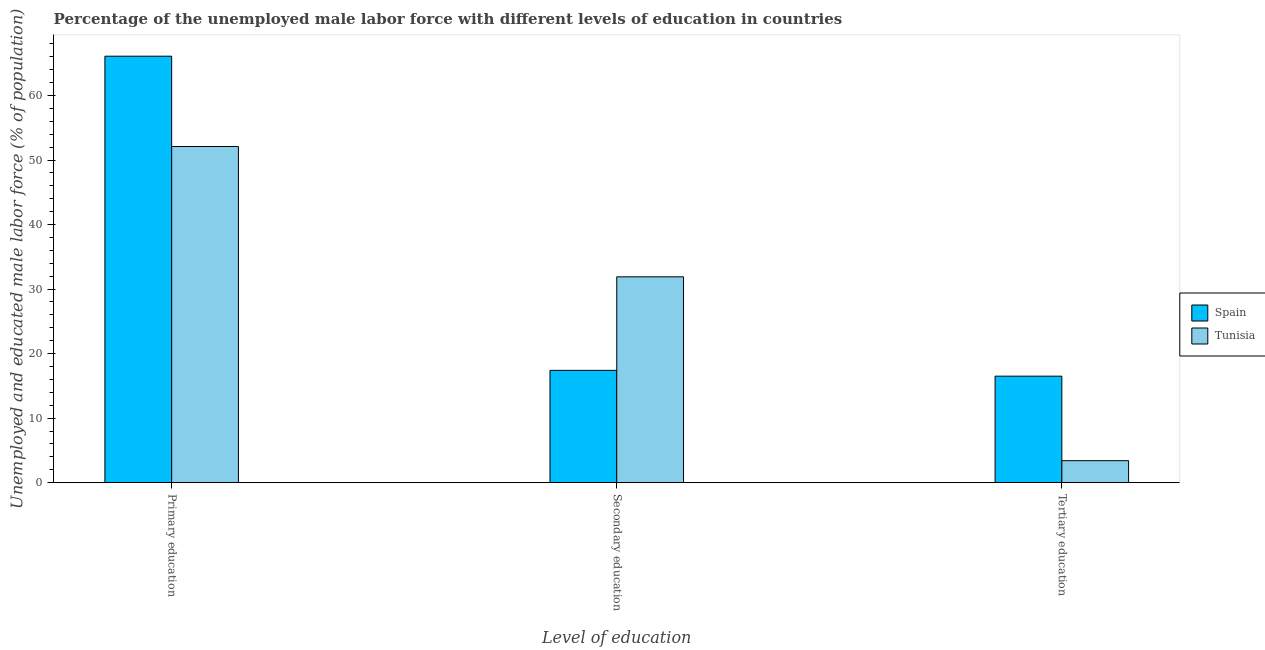How many groups of bars are there?
Make the answer very short. 3. Are the number of bars per tick equal to the number of legend labels?
Give a very brief answer. Yes. Are the number of bars on each tick of the X-axis equal?
Offer a very short reply. Yes. What is the percentage of male labor force who received tertiary education in Spain?
Your answer should be compact. 16.5. Across all countries, what is the maximum percentage of male labor force who received secondary education?
Offer a very short reply. 31.9. Across all countries, what is the minimum percentage of male labor force who received primary education?
Make the answer very short. 52.1. What is the total percentage of male labor force who received tertiary education in the graph?
Your answer should be compact. 19.9. What is the difference between the percentage of male labor force who received tertiary education in Tunisia and that in Spain?
Ensure brevity in your answer.  -13.1. What is the difference between the percentage of male labor force who received tertiary education in Tunisia and the percentage of male labor force who received primary education in Spain?
Offer a very short reply. -62.7. What is the average percentage of male labor force who received secondary education per country?
Offer a terse response. 24.65. What is the difference between the percentage of male labor force who received primary education and percentage of male labor force who received tertiary education in Tunisia?
Offer a very short reply. 48.7. In how many countries, is the percentage of male labor force who received primary education greater than 66 %?
Your response must be concise. 1. What is the ratio of the percentage of male labor force who received primary education in Spain to that in Tunisia?
Your answer should be very brief. 1.27. Is the percentage of male labor force who received primary education in Spain less than that in Tunisia?
Offer a very short reply. No. Is the difference between the percentage of male labor force who received tertiary education in Spain and Tunisia greater than the difference between the percentage of male labor force who received primary education in Spain and Tunisia?
Your answer should be compact. No. What is the difference between the highest and the second highest percentage of male labor force who received tertiary education?
Your response must be concise. 13.1. What is the difference between the highest and the lowest percentage of male labor force who received tertiary education?
Offer a terse response. 13.1. What does the 2nd bar from the left in Tertiary education represents?
Make the answer very short. Tunisia. What does the 2nd bar from the right in Tertiary education represents?
Provide a succinct answer. Spain. How many bars are there?
Offer a very short reply. 6. How many countries are there in the graph?
Provide a short and direct response. 2. Are the values on the major ticks of Y-axis written in scientific E-notation?
Make the answer very short. No. Does the graph contain grids?
Provide a short and direct response. No. How are the legend labels stacked?
Offer a very short reply. Vertical. What is the title of the graph?
Your answer should be very brief. Percentage of the unemployed male labor force with different levels of education in countries. Does "Channel Islands" appear as one of the legend labels in the graph?
Make the answer very short. No. What is the label or title of the X-axis?
Offer a terse response. Level of education. What is the label or title of the Y-axis?
Give a very brief answer. Unemployed and educated male labor force (% of population). What is the Unemployed and educated male labor force (% of population) of Spain in Primary education?
Your answer should be very brief. 66.1. What is the Unemployed and educated male labor force (% of population) in Tunisia in Primary education?
Give a very brief answer. 52.1. What is the Unemployed and educated male labor force (% of population) in Spain in Secondary education?
Offer a very short reply. 17.4. What is the Unemployed and educated male labor force (% of population) in Tunisia in Secondary education?
Provide a short and direct response. 31.9. What is the Unemployed and educated male labor force (% of population) in Tunisia in Tertiary education?
Your response must be concise. 3.4. Across all Level of education, what is the maximum Unemployed and educated male labor force (% of population) in Spain?
Your answer should be very brief. 66.1. Across all Level of education, what is the maximum Unemployed and educated male labor force (% of population) of Tunisia?
Your response must be concise. 52.1. Across all Level of education, what is the minimum Unemployed and educated male labor force (% of population) of Tunisia?
Ensure brevity in your answer.  3.4. What is the total Unemployed and educated male labor force (% of population) of Tunisia in the graph?
Provide a succinct answer. 87.4. What is the difference between the Unemployed and educated male labor force (% of population) in Spain in Primary education and that in Secondary education?
Your answer should be compact. 48.7. What is the difference between the Unemployed and educated male labor force (% of population) in Tunisia in Primary education and that in Secondary education?
Offer a terse response. 20.2. What is the difference between the Unemployed and educated male labor force (% of population) of Spain in Primary education and that in Tertiary education?
Provide a short and direct response. 49.6. What is the difference between the Unemployed and educated male labor force (% of population) of Tunisia in Primary education and that in Tertiary education?
Your answer should be very brief. 48.7. What is the difference between the Unemployed and educated male labor force (% of population) in Spain in Primary education and the Unemployed and educated male labor force (% of population) in Tunisia in Secondary education?
Your answer should be compact. 34.2. What is the difference between the Unemployed and educated male labor force (% of population) of Spain in Primary education and the Unemployed and educated male labor force (% of population) of Tunisia in Tertiary education?
Your answer should be compact. 62.7. What is the average Unemployed and educated male labor force (% of population) of Spain per Level of education?
Offer a very short reply. 33.33. What is the average Unemployed and educated male labor force (% of population) of Tunisia per Level of education?
Provide a short and direct response. 29.13. What is the difference between the Unemployed and educated male labor force (% of population) in Spain and Unemployed and educated male labor force (% of population) in Tunisia in Tertiary education?
Your response must be concise. 13.1. What is the ratio of the Unemployed and educated male labor force (% of population) of Spain in Primary education to that in Secondary education?
Provide a short and direct response. 3.8. What is the ratio of the Unemployed and educated male labor force (% of population) in Tunisia in Primary education to that in Secondary education?
Keep it short and to the point. 1.63. What is the ratio of the Unemployed and educated male labor force (% of population) in Spain in Primary education to that in Tertiary education?
Your response must be concise. 4.01. What is the ratio of the Unemployed and educated male labor force (% of population) in Tunisia in Primary education to that in Tertiary education?
Provide a short and direct response. 15.32. What is the ratio of the Unemployed and educated male labor force (% of population) in Spain in Secondary education to that in Tertiary education?
Keep it short and to the point. 1.05. What is the ratio of the Unemployed and educated male labor force (% of population) of Tunisia in Secondary education to that in Tertiary education?
Give a very brief answer. 9.38. What is the difference between the highest and the second highest Unemployed and educated male labor force (% of population) of Spain?
Offer a terse response. 48.7. What is the difference between the highest and the second highest Unemployed and educated male labor force (% of population) in Tunisia?
Give a very brief answer. 20.2. What is the difference between the highest and the lowest Unemployed and educated male labor force (% of population) of Spain?
Your answer should be compact. 49.6. What is the difference between the highest and the lowest Unemployed and educated male labor force (% of population) of Tunisia?
Provide a succinct answer. 48.7. 